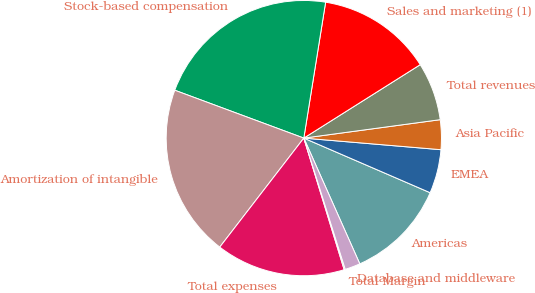Convert chart. <chart><loc_0><loc_0><loc_500><loc_500><pie_chart><fcel>Americas<fcel>EMEA<fcel>Asia Pacific<fcel>Total revenues<fcel>Sales and marketing (1)<fcel>Stock-based compensation<fcel>Amortization of intangible<fcel>Total expenses<fcel>Total Margin<fcel>Database and middleware<nl><fcel>11.84%<fcel>5.15%<fcel>3.48%<fcel>6.82%<fcel>13.51%<fcel>21.88%<fcel>20.2%<fcel>15.19%<fcel>0.13%<fcel>1.8%<nl></chart> 